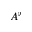Convert formula to latex. <formula><loc_0><loc_0><loc_500><loc_500>A ^ { \flat }</formula> 